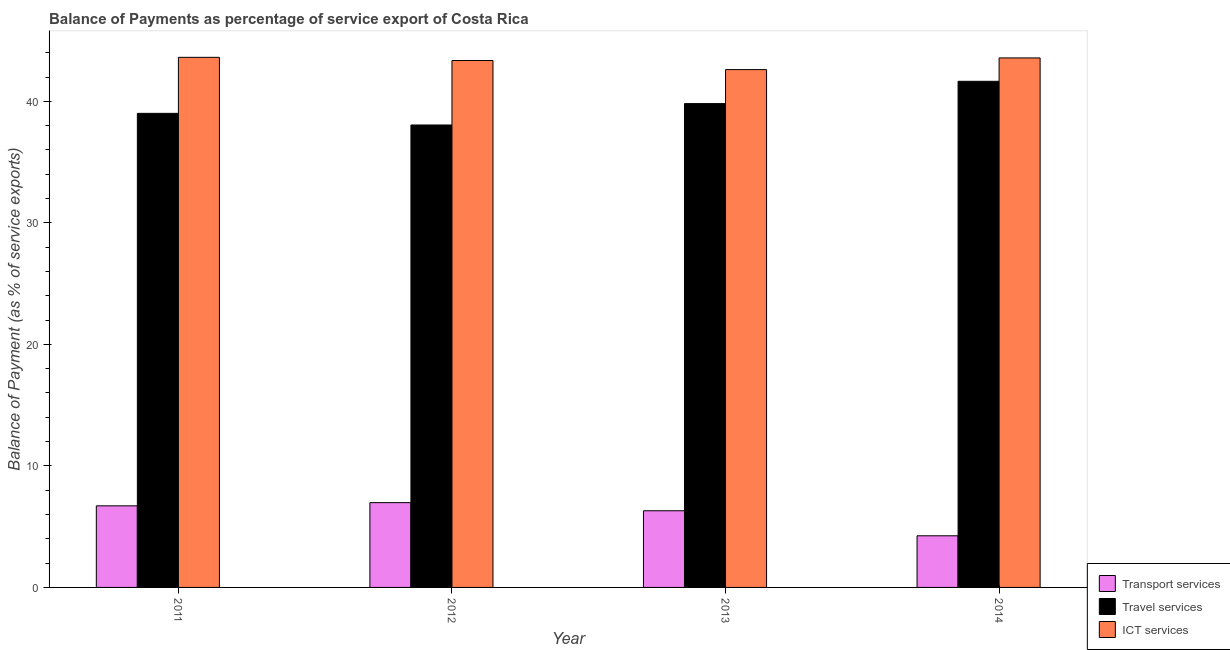How many different coloured bars are there?
Offer a terse response. 3. How many groups of bars are there?
Make the answer very short. 4. Are the number of bars per tick equal to the number of legend labels?
Your response must be concise. Yes. Are the number of bars on each tick of the X-axis equal?
Make the answer very short. Yes. What is the label of the 3rd group of bars from the left?
Offer a very short reply. 2013. What is the balance of payment of transport services in 2013?
Provide a succinct answer. 6.31. Across all years, what is the maximum balance of payment of ict services?
Your response must be concise. 43.62. Across all years, what is the minimum balance of payment of transport services?
Offer a very short reply. 4.25. What is the total balance of payment of transport services in the graph?
Make the answer very short. 24.25. What is the difference between the balance of payment of travel services in 2012 and that in 2013?
Your response must be concise. -1.76. What is the difference between the balance of payment of travel services in 2013 and the balance of payment of transport services in 2012?
Ensure brevity in your answer.  1.76. What is the average balance of payment of travel services per year?
Keep it short and to the point. 39.63. In the year 2012, what is the difference between the balance of payment of travel services and balance of payment of ict services?
Your answer should be compact. 0. What is the ratio of the balance of payment of travel services in 2011 to that in 2013?
Make the answer very short. 0.98. Is the balance of payment of travel services in 2011 less than that in 2012?
Your response must be concise. No. Is the difference between the balance of payment of transport services in 2011 and 2012 greater than the difference between the balance of payment of travel services in 2011 and 2012?
Provide a short and direct response. No. What is the difference between the highest and the second highest balance of payment of travel services?
Ensure brevity in your answer.  1.83. What is the difference between the highest and the lowest balance of payment of transport services?
Offer a very short reply. 2.73. Is the sum of the balance of payment of ict services in 2012 and 2013 greater than the maximum balance of payment of transport services across all years?
Keep it short and to the point. Yes. What does the 1st bar from the left in 2014 represents?
Make the answer very short. Transport services. What does the 2nd bar from the right in 2012 represents?
Make the answer very short. Travel services. How many bars are there?
Your answer should be very brief. 12. Are all the bars in the graph horizontal?
Give a very brief answer. No. Does the graph contain grids?
Provide a succinct answer. No. Where does the legend appear in the graph?
Offer a terse response. Bottom right. How many legend labels are there?
Provide a short and direct response. 3. How are the legend labels stacked?
Offer a terse response. Vertical. What is the title of the graph?
Keep it short and to the point. Balance of Payments as percentage of service export of Costa Rica. What is the label or title of the X-axis?
Your response must be concise. Year. What is the label or title of the Y-axis?
Your answer should be very brief. Balance of Payment (as % of service exports). What is the Balance of Payment (as % of service exports) in Transport services in 2011?
Provide a succinct answer. 6.71. What is the Balance of Payment (as % of service exports) of Travel services in 2011?
Your answer should be very brief. 39.01. What is the Balance of Payment (as % of service exports) of ICT services in 2011?
Your answer should be compact. 43.62. What is the Balance of Payment (as % of service exports) in Transport services in 2012?
Offer a terse response. 6.98. What is the Balance of Payment (as % of service exports) of Travel services in 2012?
Provide a short and direct response. 38.05. What is the Balance of Payment (as % of service exports) in ICT services in 2012?
Make the answer very short. 43.36. What is the Balance of Payment (as % of service exports) of Transport services in 2013?
Offer a very short reply. 6.31. What is the Balance of Payment (as % of service exports) in Travel services in 2013?
Offer a very short reply. 39.81. What is the Balance of Payment (as % of service exports) in ICT services in 2013?
Ensure brevity in your answer.  42.61. What is the Balance of Payment (as % of service exports) of Transport services in 2014?
Your response must be concise. 4.25. What is the Balance of Payment (as % of service exports) of Travel services in 2014?
Offer a very short reply. 41.65. What is the Balance of Payment (as % of service exports) in ICT services in 2014?
Your answer should be very brief. 43.57. Across all years, what is the maximum Balance of Payment (as % of service exports) of Transport services?
Keep it short and to the point. 6.98. Across all years, what is the maximum Balance of Payment (as % of service exports) of Travel services?
Make the answer very short. 41.65. Across all years, what is the maximum Balance of Payment (as % of service exports) in ICT services?
Offer a terse response. 43.62. Across all years, what is the minimum Balance of Payment (as % of service exports) of Transport services?
Provide a short and direct response. 4.25. Across all years, what is the minimum Balance of Payment (as % of service exports) in Travel services?
Ensure brevity in your answer.  38.05. Across all years, what is the minimum Balance of Payment (as % of service exports) in ICT services?
Make the answer very short. 42.61. What is the total Balance of Payment (as % of service exports) of Transport services in the graph?
Provide a succinct answer. 24.25. What is the total Balance of Payment (as % of service exports) in Travel services in the graph?
Provide a succinct answer. 158.53. What is the total Balance of Payment (as % of service exports) in ICT services in the graph?
Your response must be concise. 173.17. What is the difference between the Balance of Payment (as % of service exports) in Transport services in 2011 and that in 2012?
Provide a succinct answer. -0.26. What is the difference between the Balance of Payment (as % of service exports) in Travel services in 2011 and that in 2012?
Keep it short and to the point. 0.96. What is the difference between the Balance of Payment (as % of service exports) of ICT services in 2011 and that in 2012?
Your answer should be compact. 0.26. What is the difference between the Balance of Payment (as % of service exports) in Transport services in 2011 and that in 2013?
Offer a terse response. 0.41. What is the difference between the Balance of Payment (as % of service exports) of Travel services in 2011 and that in 2013?
Keep it short and to the point. -0.8. What is the difference between the Balance of Payment (as % of service exports) in ICT services in 2011 and that in 2013?
Ensure brevity in your answer.  1.01. What is the difference between the Balance of Payment (as % of service exports) in Transport services in 2011 and that in 2014?
Provide a succinct answer. 2.46. What is the difference between the Balance of Payment (as % of service exports) of Travel services in 2011 and that in 2014?
Ensure brevity in your answer.  -2.64. What is the difference between the Balance of Payment (as % of service exports) in ICT services in 2011 and that in 2014?
Give a very brief answer. 0.05. What is the difference between the Balance of Payment (as % of service exports) in Transport services in 2012 and that in 2013?
Provide a short and direct response. 0.67. What is the difference between the Balance of Payment (as % of service exports) in Travel services in 2012 and that in 2013?
Provide a short and direct response. -1.76. What is the difference between the Balance of Payment (as % of service exports) in ICT services in 2012 and that in 2013?
Provide a short and direct response. 0.75. What is the difference between the Balance of Payment (as % of service exports) of Transport services in 2012 and that in 2014?
Your answer should be compact. 2.73. What is the difference between the Balance of Payment (as % of service exports) of Travel services in 2012 and that in 2014?
Provide a succinct answer. -3.6. What is the difference between the Balance of Payment (as % of service exports) in ICT services in 2012 and that in 2014?
Offer a terse response. -0.21. What is the difference between the Balance of Payment (as % of service exports) of Transport services in 2013 and that in 2014?
Ensure brevity in your answer.  2.06. What is the difference between the Balance of Payment (as % of service exports) of Travel services in 2013 and that in 2014?
Offer a very short reply. -1.83. What is the difference between the Balance of Payment (as % of service exports) in ICT services in 2013 and that in 2014?
Provide a short and direct response. -0.96. What is the difference between the Balance of Payment (as % of service exports) of Transport services in 2011 and the Balance of Payment (as % of service exports) of Travel services in 2012?
Ensure brevity in your answer.  -31.34. What is the difference between the Balance of Payment (as % of service exports) in Transport services in 2011 and the Balance of Payment (as % of service exports) in ICT services in 2012?
Keep it short and to the point. -36.65. What is the difference between the Balance of Payment (as % of service exports) of Travel services in 2011 and the Balance of Payment (as % of service exports) of ICT services in 2012?
Your response must be concise. -4.35. What is the difference between the Balance of Payment (as % of service exports) of Transport services in 2011 and the Balance of Payment (as % of service exports) of Travel services in 2013?
Provide a short and direct response. -33.1. What is the difference between the Balance of Payment (as % of service exports) of Transport services in 2011 and the Balance of Payment (as % of service exports) of ICT services in 2013?
Provide a succinct answer. -35.9. What is the difference between the Balance of Payment (as % of service exports) of Travel services in 2011 and the Balance of Payment (as % of service exports) of ICT services in 2013?
Provide a succinct answer. -3.6. What is the difference between the Balance of Payment (as % of service exports) of Transport services in 2011 and the Balance of Payment (as % of service exports) of Travel services in 2014?
Provide a succinct answer. -34.93. What is the difference between the Balance of Payment (as % of service exports) in Transport services in 2011 and the Balance of Payment (as % of service exports) in ICT services in 2014?
Offer a very short reply. -36.86. What is the difference between the Balance of Payment (as % of service exports) in Travel services in 2011 and the Balance of Payment (as % of service exports) in ICT services in 2014?
Your answer should be compact. -4.56. What is the difference between the Balance of Payment (as % of service exports) in Transport services in 2012 and the Balance of Payment (as % of service exports) in Travel services in 2013?
Provide a short and direct response. -32.84. What is the difference between the Balance of Payment (as % of service exports) in Transport services in 2012 and the Balance of Payment (as % of service exports) in ICT services in 2013?
Your answer should be very brief. -35.64. What is the difference between the Balance of Payment (as % of service exports) of Travel services in 2012 and the Balance of Payment (as % of service exports) of ICT services in 2013?
Make the answer very short. -4.56. What is the difference between the Balance of Payment (as % of service exports) of Transport services in 2012 and the Balance of Payment (as % of service exports) of Travel services in 2014?
Your answer should be very brief. -34.67. What is the difference between the Balance of Payment (as % of service exports) in Transport services in 2012 and the Balance of Payment (as % of service exports) in ICT services in 2014?
Your response must be concise. -36.6. What is the difference between the Balance of Payment (as % of service exports) in Travel services in 2012 and the Balance of Payment (as % of service exports) in ICT services in 2014?
Provide a short and direct response. -5.52. What is the difference between the Balance of Payment (as % of service exports) in Transport services in 2013 and the Balance of Payment (as % of service exports) in Travel services in 2014?
Provide a short and direct response. -35.34. What is the difference between the Balance of Payment (as % of service exports) of Transport services in 2013 and the Balance of Payment (as % of service exports) of ICT services in 2014?
Offer a very short reply. -37.26. What is the difference between the Balance of Payment (as % of service exports) in Travel services in 2013 and the Balance of Payment (as % of service exports) in ICT services in 2014?
Make the answer very short. -3.76. What is the average Balance of Payment (as % of service exports) of Transport services per year?
Your response must be concise. 6.06. What is the average Balance of Payment (as % of service exports) of Travel services per year?
Keep it short and to the point. 39.63. What is the average Balance of Payment (as % of service exports) of ICT services per year?
Your response must be concise. 43.29. In the year 2011, what is the difference between the Balance of Payment (as % of service exports) in Transport services and Balance of Payment (as % of service exports) in Travel services?
Your answer should be compact. -32.3. In the year 2011, what is the difference between the Balance of Payment (as % of service exports) of Transport services and Balance of Payment (as % of service exports) of ICT services?
Offer a terse response. -36.91. In the year 2011, what is the difference between the Balance of Payment (as % of service exports) of Travel services and Balance of Payment (as % of service exports) of ICT services?
Ensure brevity in your answer.  -4.61. In the year 2012, what is the difference between the Balance of Payment (as % of service exports) in Transport services and Balance of Payment (as % of service exports) in Travel services?
Offer a terse response. -31.08. In the year 2012, what is the difference between the Balance of Payment (as % of service exports) in Transport services and Balance of Payment (as % of service exports) in ICT services?
Provide a succinct answer. -36.38. In the year 2012, what is the difference between the Balance of Payment (as % of service exports) of Travel services and Balance of Payment (as % of service exports) of ICT services?
Your answer should be compact. -5.31. In the year 2013, what is the difference between the Balance of Payment (as % of service exports) of Transport services and Balance of Payment (as % of service exports) of Travel services?
Your response must be concise. -33.51. In the year 2013, what is the difference between the Balance of Payment (as % of service exports) of Transport services and Balance of Payment (as % of service exports) of ICT services?
Your response must be concise. -36.3. In the year 2013, what is the difference between the Balance of Payment (as % of service exports) in Travel services and Balance of Payment (as % of service exports) in ICT services?
Provide a succinct answer. -2.8. In the year 2014, what is the difference between the Balance of Payment (as % of service exports) of Transport services and Balance of Payment (as % of service exports) of Travel services?
Give a very brief answer. -37.4. In the year 2014, what is the difference between the Balance of Payment (as % of service exports) of Transport services and Balance of Payment (as % of service exports) of ICT services?
Give a very brief answer. -39.32. In the year 2014, what is the difference between the Balance of Payment (as % of service exports) of Travel services and Balance of Payment (as % of service exports) of ICT services?
Give a very brief answer. -1.92. What is the ratio of the Balance of Payment (as % of service exports) in Transport services in 2011 to that in 2012?
Offer a very short reply. 0.96. What is the ratio of the Balance of Payment (as % of service exports) of Travel services in 2011 to that in 2012?
Your answer should be very brief. 1.03. What is the ratio of the Balance of Payment (as % of service exports) of ICT services in 2011 to that in 2012?
Provide a short and direct response. 1.01. What is the ratio of the Balance of Payment (as % of service exports) in Transport services in 2011 to that in 2013?
Offer a terse response. 1.06. What is the ratio of the Balance of Payment (as % of service exports) in Travel services in 2011 to that in 2013?
Your answer should be compact. 0.98. What is the ratio of the Balance of Payment (as % of service exports) in ICT services in 2011 to that in 2013?
Provide a short and direct response. 1.02. What is the ratio of the Balance of Payment (as % of service exports) of Transport services in 2011 to that in 2014?
Keep it short and to the point. 1.58. What is the ratio of the Balance of Payment (as % of service exports) of Travel services in 2011 to that in 2014?
Keep it short and to the point. 0.94. What is the ratio of the Balance of Payment (as % of service exports) of Transport services in 2012 to that in 2013?
Make the answer very short. 1.11. What is the ratio of the Balance of Payment (as % of service exports) of Travel services in 2012 to that in 2013?
Ensure brevity in your answer.  0.96. What is the ratio of the Balance of Payment (as % of service exports) in ICT services in 2012 to that in 2013?
Ensure brevity in your answer.  1.02. What is the ratio of the Balance of Payment (as % of service exports) of Transport services in 2012 to that in 2014?
Give a very brief answer. 1.64. What is the ratio of the Balance of Payment (as % of service exports) in Travel services in 2012 to that in 2014?
Give a very brief answer. 0.91. What is the ratio of the Balance of Payment (as % of service exports) of Transport services in 2013 to that in 2014?
Provide a short and direct response. 1.48. What is the ratio of the Balance of Payment (as % of service exports) in Travel services in 2013 to that in 2014?
Keep it short and to the point. 0.96. What is the ratio of the Balance of Payment (as % of service exports) in ICT services in 2013 to that in 2014?
Offer a very short reply. 0.98. What is the difference between the highest and the second highest Balance of Payment (as % of service exports) in Transport services?
Ensure brevity in your answer.  0.26. What is the difference between the highest and the second highest Balance of Payment (as % of service exports) of Travel services?
Keep it short and to the point. 1.83. What is the difference between the highest and the second highest Balance of Payment (as % of service exports) of ICT services?
Your response must be concise. 0.05. What is the difference between the highest and the lowest Balance of Payment (as % of service exports) of Transport services?
Ensure brevity in your answer.  2.73. What is the difference between the highest and the lowest Balance of Payment (as % of service exports) of Travel services?
Provide a short and direct response. 3.6. What is the difference between the highest and the lowest Balance of Payment (as % of service exports) in ICT services?
Provide a short and direct response. 1.01. 